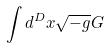<formula> <loc_0><loc_0><loc_500><loc_500>\int d ^ { D } x \sqrt { - g } G</formula> 